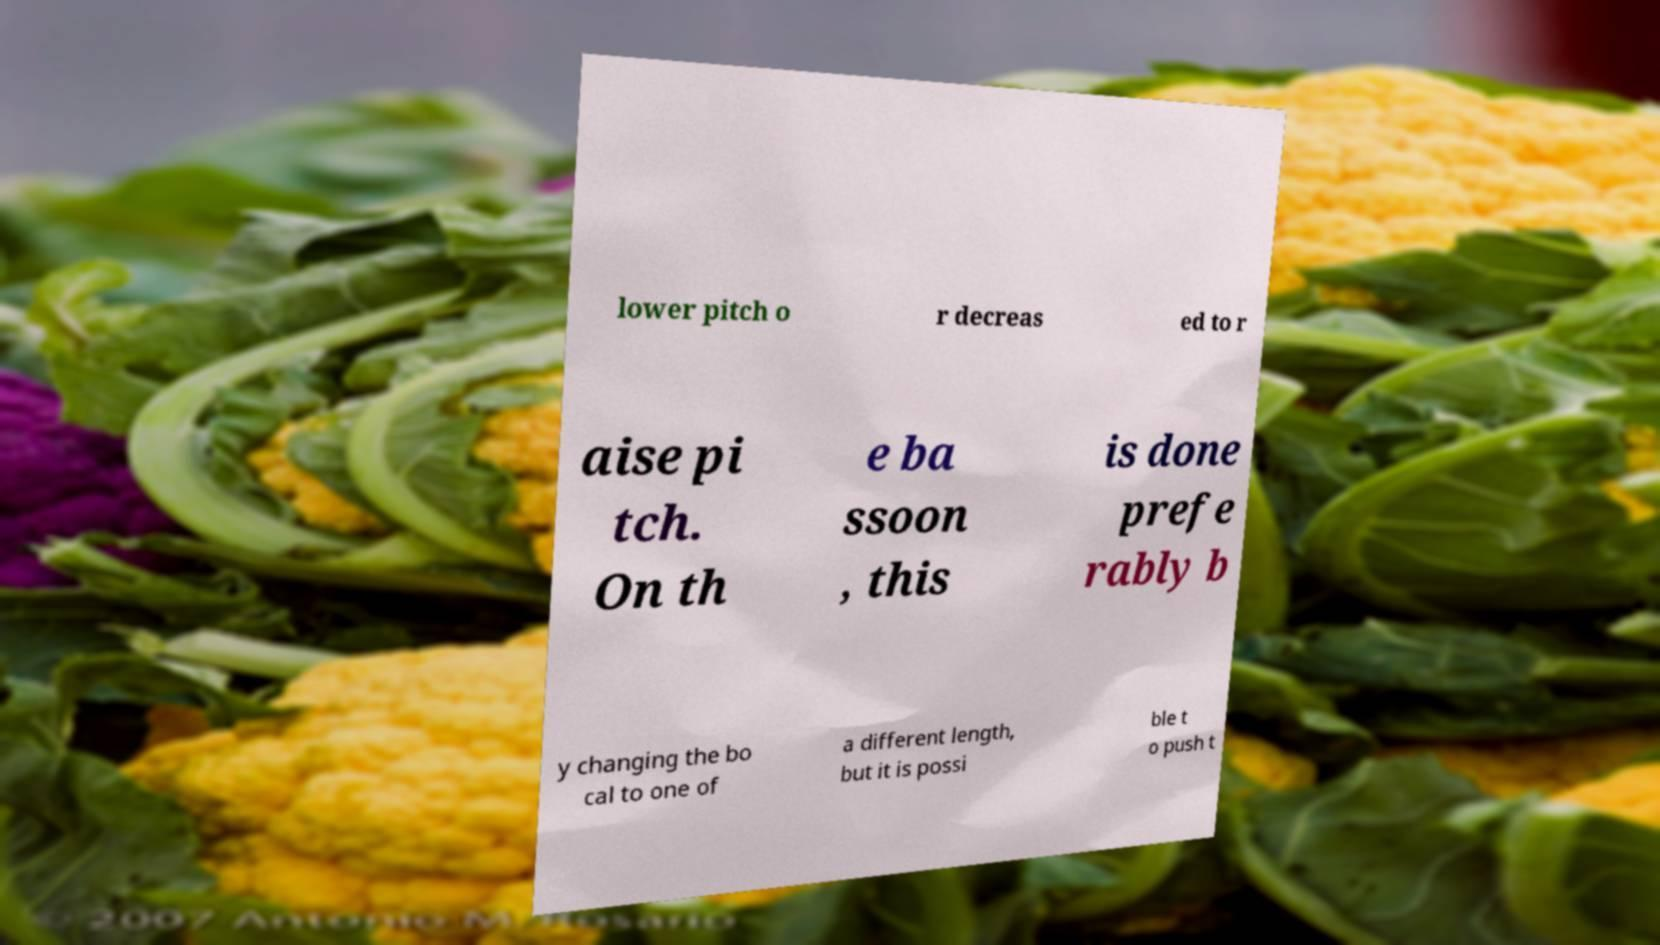Can you accurately transcribe the text from the provided image for me? lower pitch o r decreas ed to r aise pi tch. On th e ba ssoon , this is done prefe rably b y changing the bo cal to one of a different length, but it is possi ble t o push t 